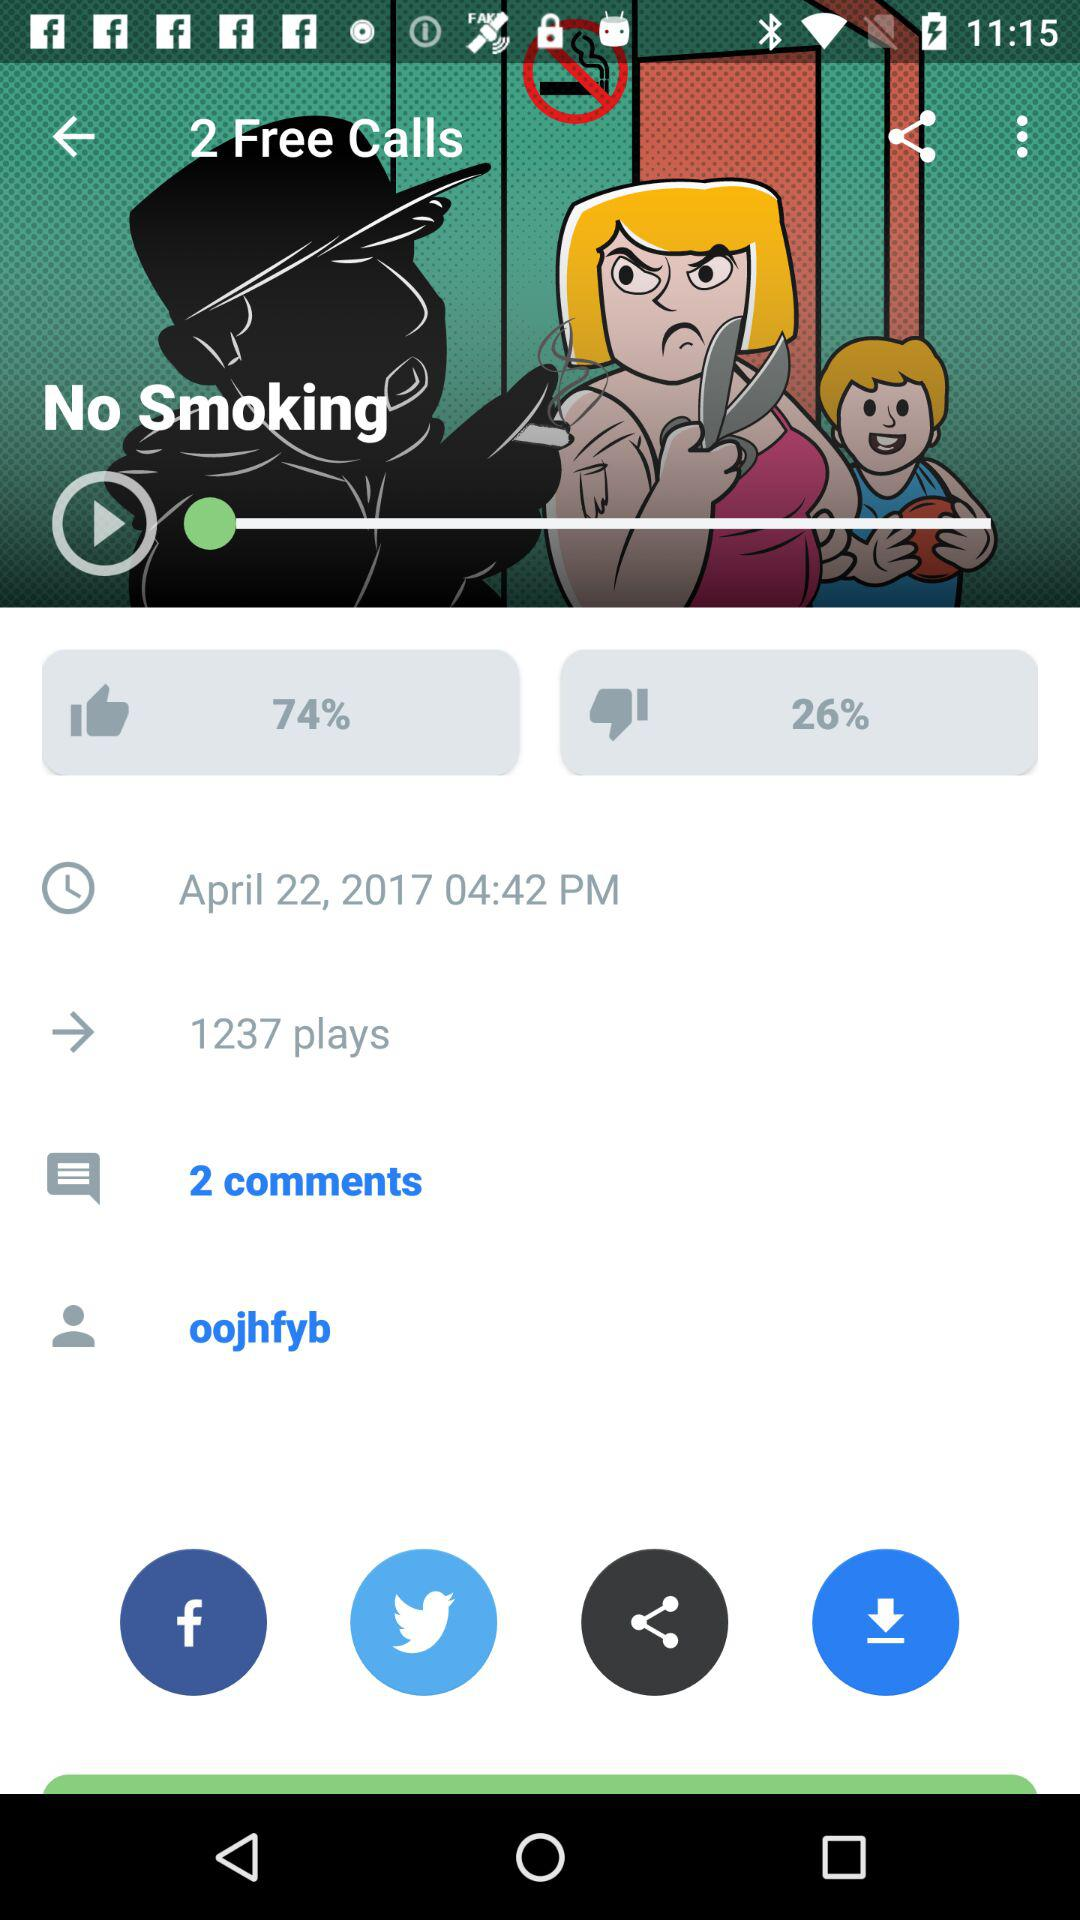What is the date and time? The date is April 22, 2017 and the time is 4:42 PM. 